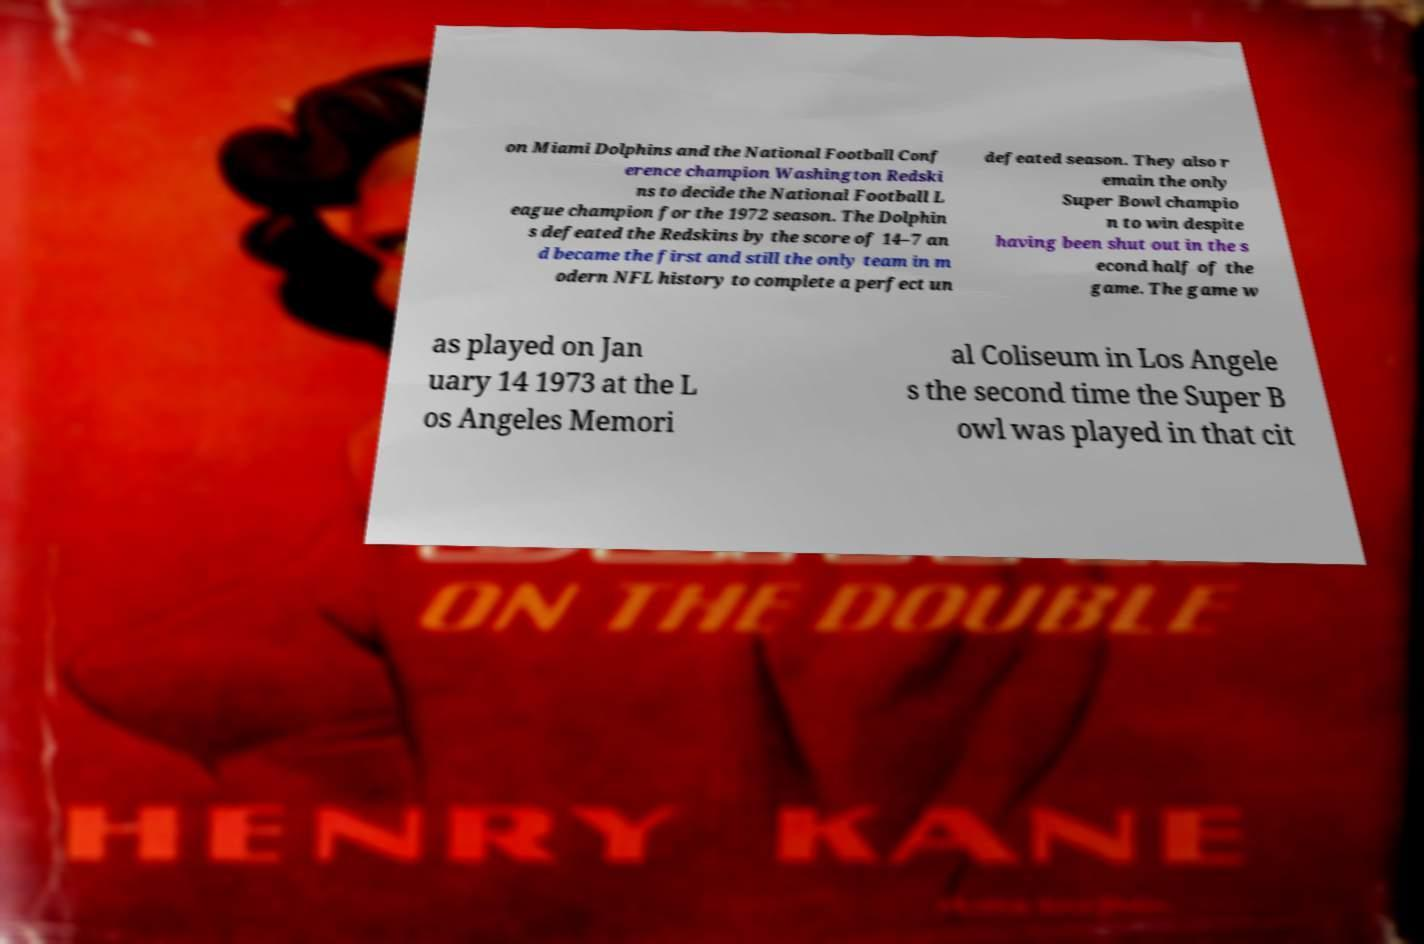Can you read and provide the text displayed in the image?This photo seems to have some interesting text. Can you extract and type it out for me? on Miami Dolphins and the National Football Conf erence champion Washington Redski ns to decide the National Football L eague champion for the 1972 season. The Dolphin s defeated the Redskins by the score of 14–7 an d became the first and still the only team in m odern NFL history to complete a perfect un defeated season. They also r emain the only Super Bowl champio n to win despite having been shut out in the s econd half of the game. The game w as played on Jan uary 14 1973 at the L os Angeles Memori al Coliseum in Los Angele s the second time the Super B owl was played in that cit 